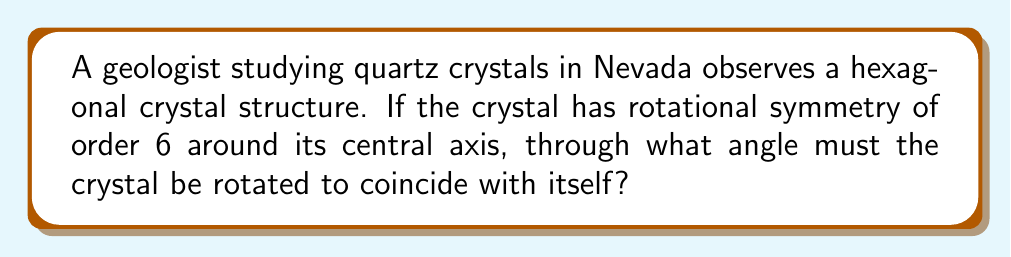Provide a solution to this math problem. Let's approach this step-by-step:

1) Rotational symmetry of order 6 means that the crystal will coincide with itself 6 times in a full 360° rotation.

2) To find the angle of rotation, we need to divide the full rotation by the order of symmetry:

   $$\text{Angle of rotation} = \frac{360°}{\text{Order of symmetry}}$$

3) In this case:
   $$\text{Angle of rotation} = \frac{360°}{6}$$

4) Simplifying:
   $$\text{Angle of rotation} = 60°$$

5) Therefore, the crystal must be rotated through 60° to coincide with itself.

This 60° rotation is a geometric transformation that preserves the symmetry of the crystal structure. Each 60° rotation will bring the crystal into a position indistinguishable from its original orientation, reflecting the hexagonal symmetry typical of quartz crystals.
Answer: 60° 